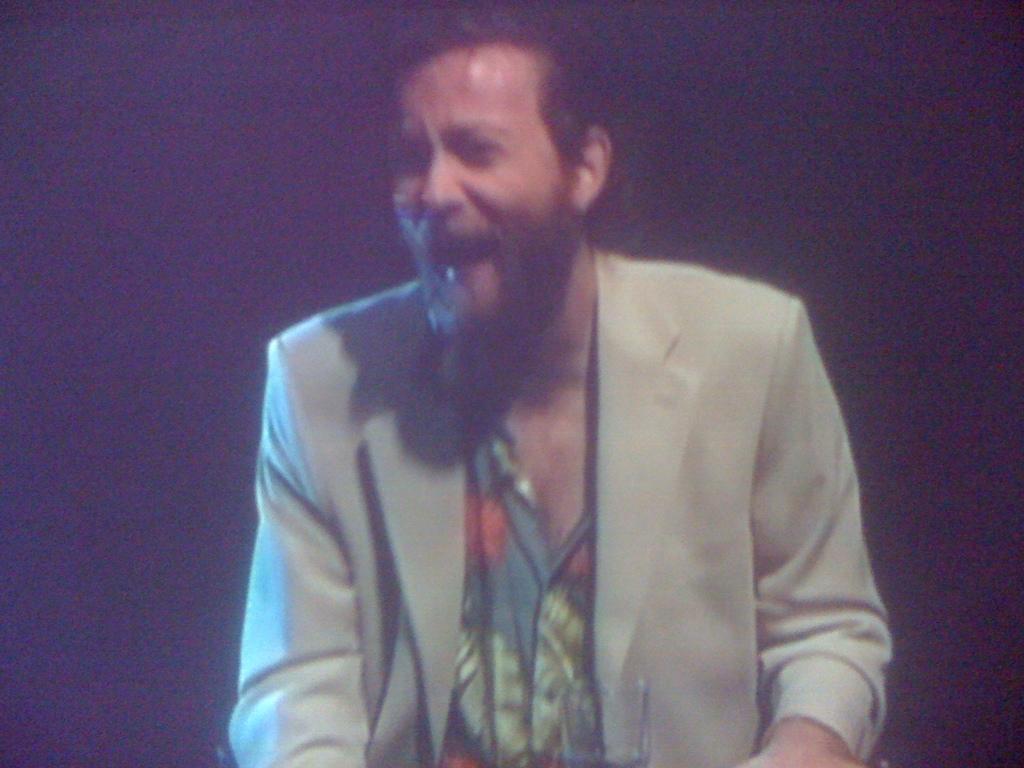Could you give a brief overview of what you see in this image? In this image there is a person smiling. 